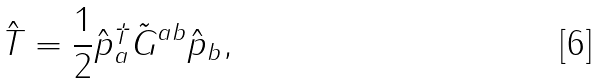<formula> <loc_0><loc_0><loc_500><loc_500>\hat { T } = \frac { 1 } { 2 } \hat { p } _ { a } ^ { \dagger } \tilde { G } ^ { a b } \hat { p } _ { b } ,</formula> 